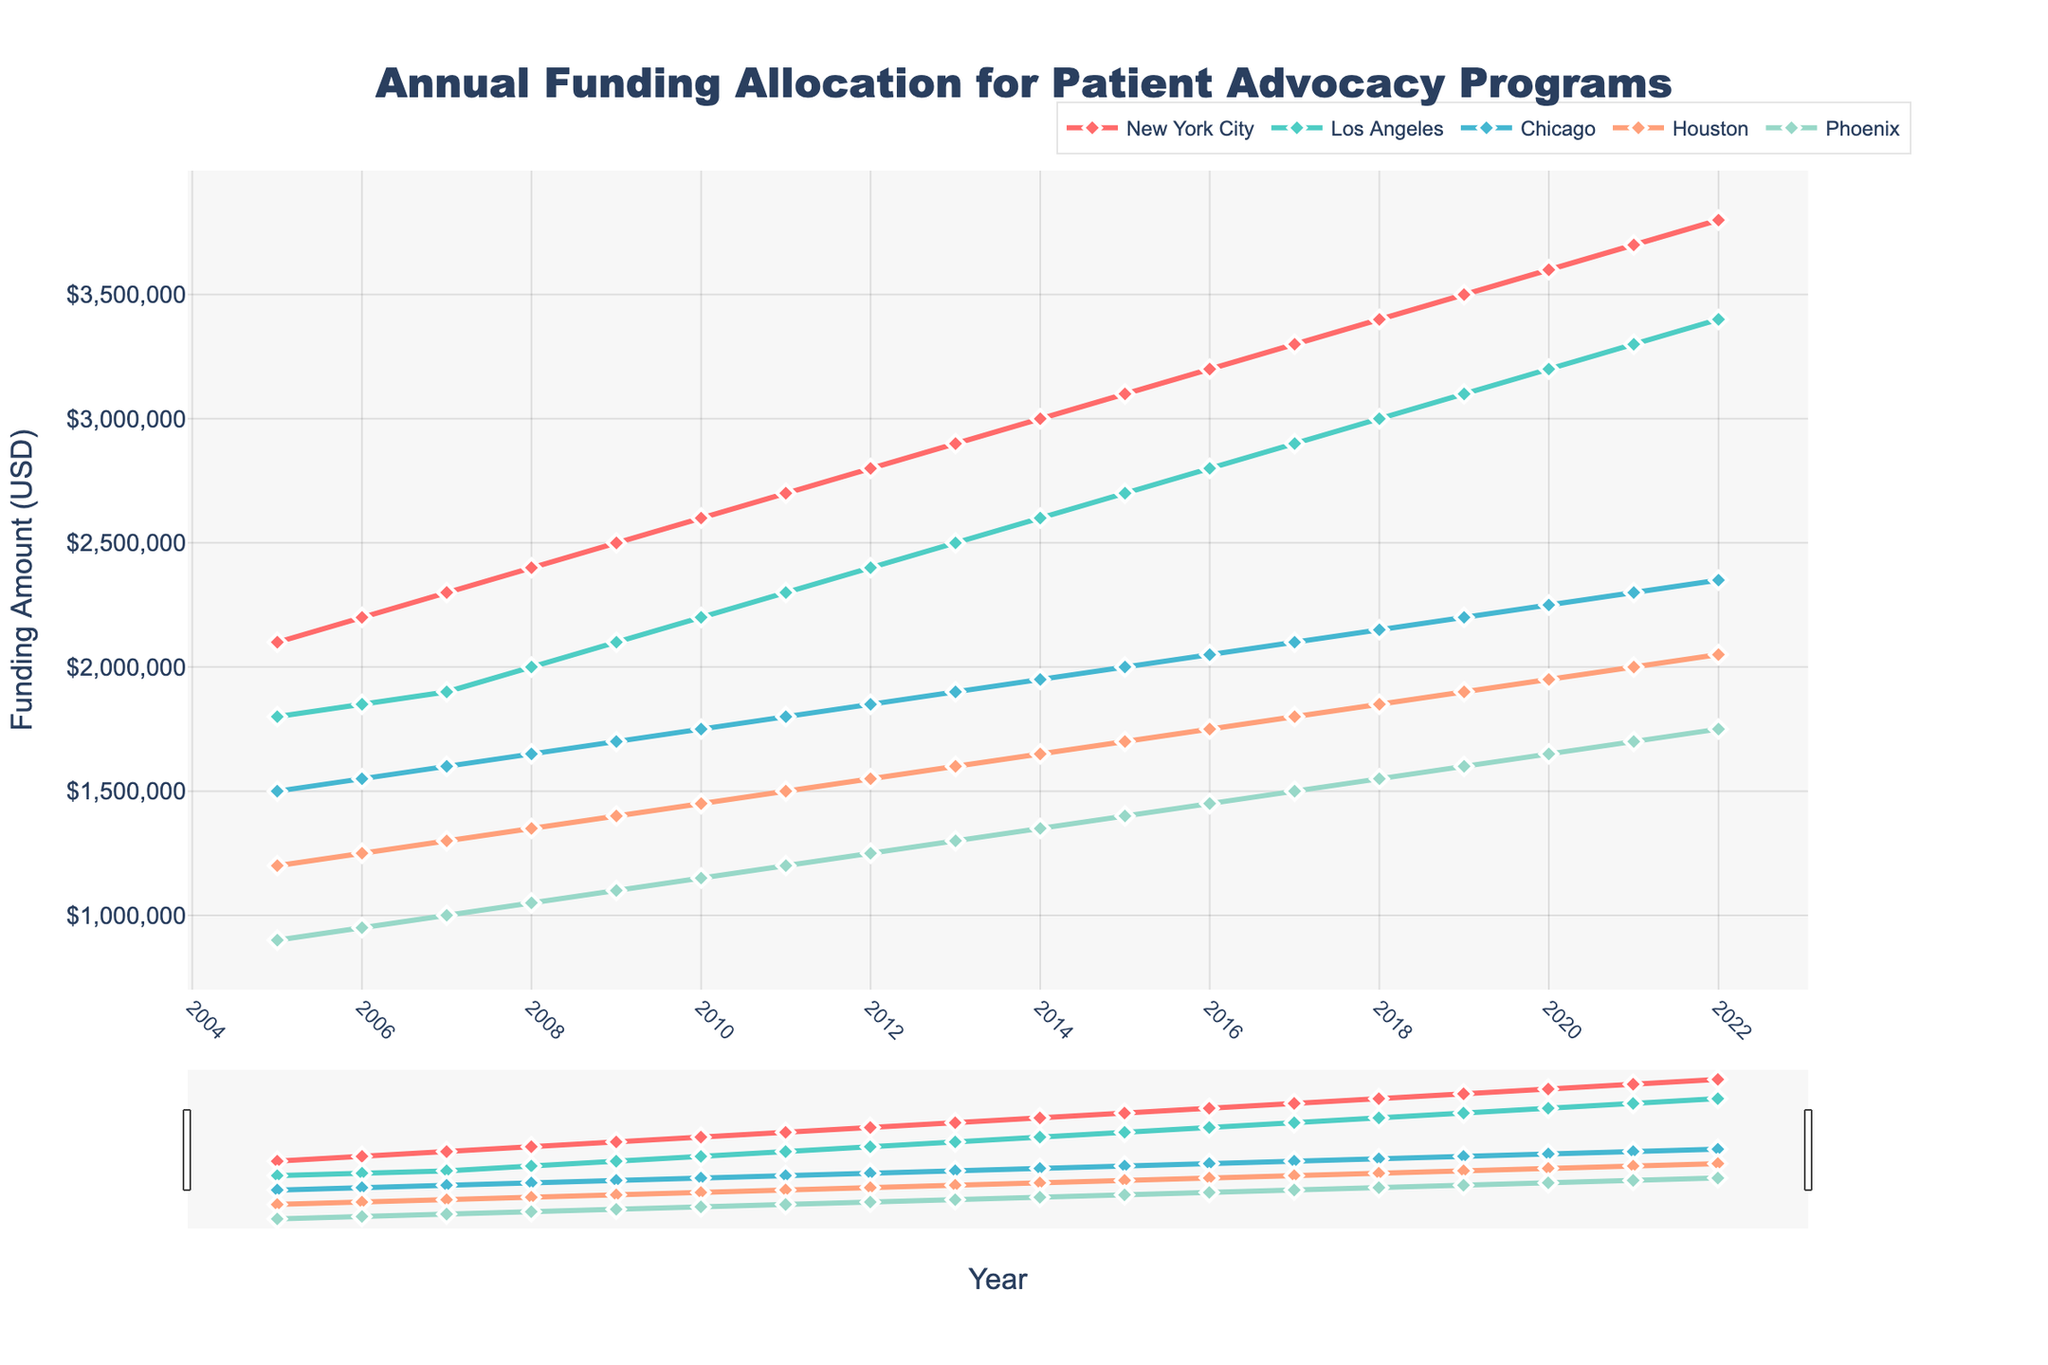Which city had the highest funding allocation in 2022? The chart shows the funding allocation for each city in different colors. By looking at the values for 2022, New York City has the highest funding allocation.
Answer: New York City What is the difference in funding between New York City and Phoenix in 2022? Locate the funding values for New York City and Phoenix in 2022. New York City has $3,800,000 and Phoenix has $1,750,000. Subtract Phoenix's funding from New York City's funding: $3,800,000 - $1,750,000 = $2,050,000.
Answer: $2,050,000 By how much did the funding for Los Angeles increase from 2005 to 2022? Find the funding values for Los Angeles in 2005 and 2022. Los Angeles had $1,800,000 in 2005 and $3,400,000 in 2022. Subtract the 2005 value from the 2022 value: $3,400,000 - $1,800,000 = $1,600,000.
Answer: $1,600,000 Which city showed the most consistent increase in funding over the years? Examine the trend lines for each city. All cities show consistent increases, but New York City's line shows the most consistent and steady increase without fluctuations.
Answer: New York City What is the average annual funding for Chicago from 2005 to 2022? Add the annual funding values for Chicago from 2005 to 2022 and divide by the number of years (18). The total is $59,850,000. Divide by 18: $59,850,000 / 18 ≈ $3,325,000.
Answer: Approximately $3,325,000 In which year did Houston surpass a funding allocation of $1,500,000? Find the first year when Houston's funding exceeds $1,500,000. By inspecting the trend, Houston surpassed $1,500,000 in 2011.
Answer: 2011 How does the funding for Phoenix in 2020 compare to that in 2005? Look at the values for Phoenix in 2005 and 2020. Phoenix had $900,000 in 2005 and $1,650,000 in 2020. The 2020 funding is greater than the 2005 funding.
Answer: Greater Identify the city with the least funding allocation in 2017 and state its value. Check the funding allocations for all cities in 2017. Phoenix has the least funding with $1,500,000.
Answer: Phoenix, $1,500,000 What was the cumulative funding allocation for all cities in 2010? Sum the funding values for all cities in 2010. The values are New York City $2,600,000, Los Angeles $2,200,000, Chicago $1,750,000, Houston $1,450,000, Phoenix $1,150,000. The cumulative amount is $2,600,000 + $2,200,000 + $1,750,000 + $1,450,000 + $1,150,000 = $9,150,000.
Answer: $9,150,000 